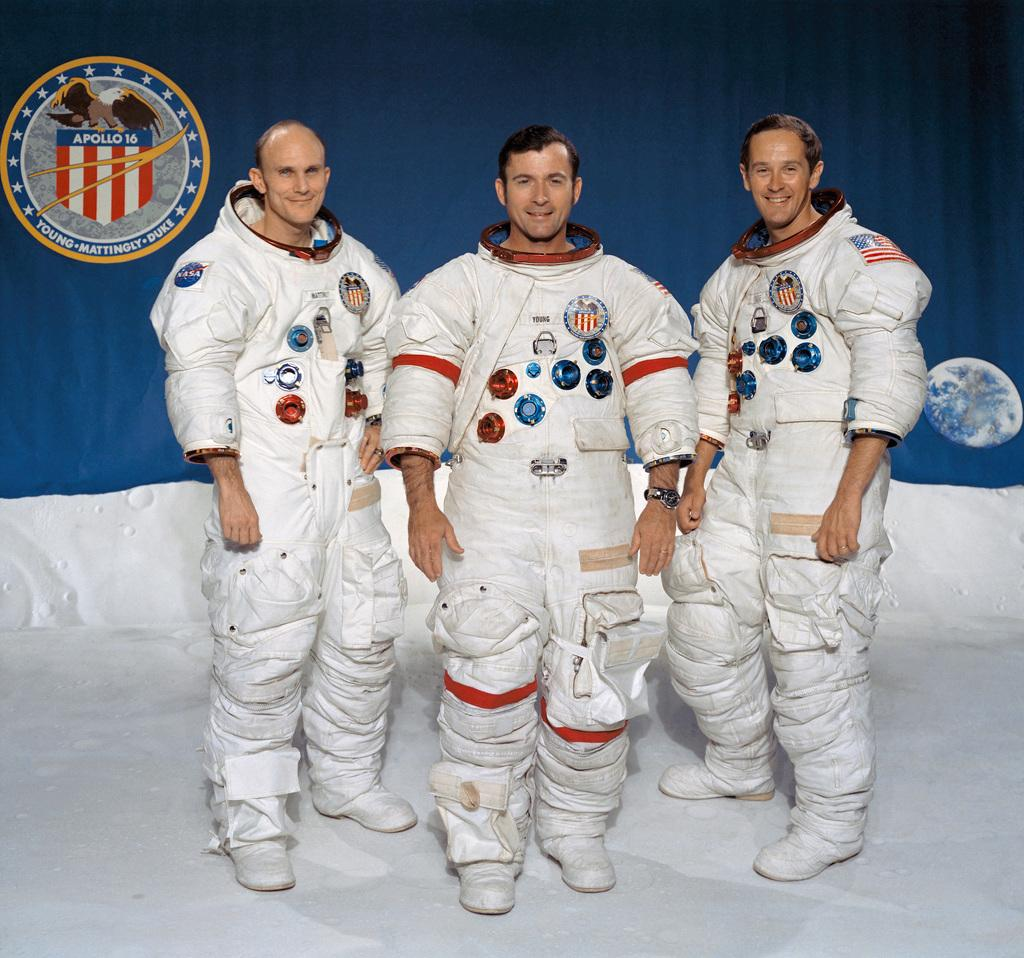How many people are in the image? There are three persons in the image. What are the persons doing in the image? The persons are standing on the floor. What are the persons wearing in the image? The persons are wearing astronaut dress. What can be seen in the background of the image? There is a poster in the background. What is depicted on the poster? The poster has an emblem on it and an image of a moon. What is the income of the persons in the image? There is no information about the income of the persons in the image. What type of punishment is being depicted on the poster? The poster does not depict any punishment; it has an emblem and an image of a moon. 